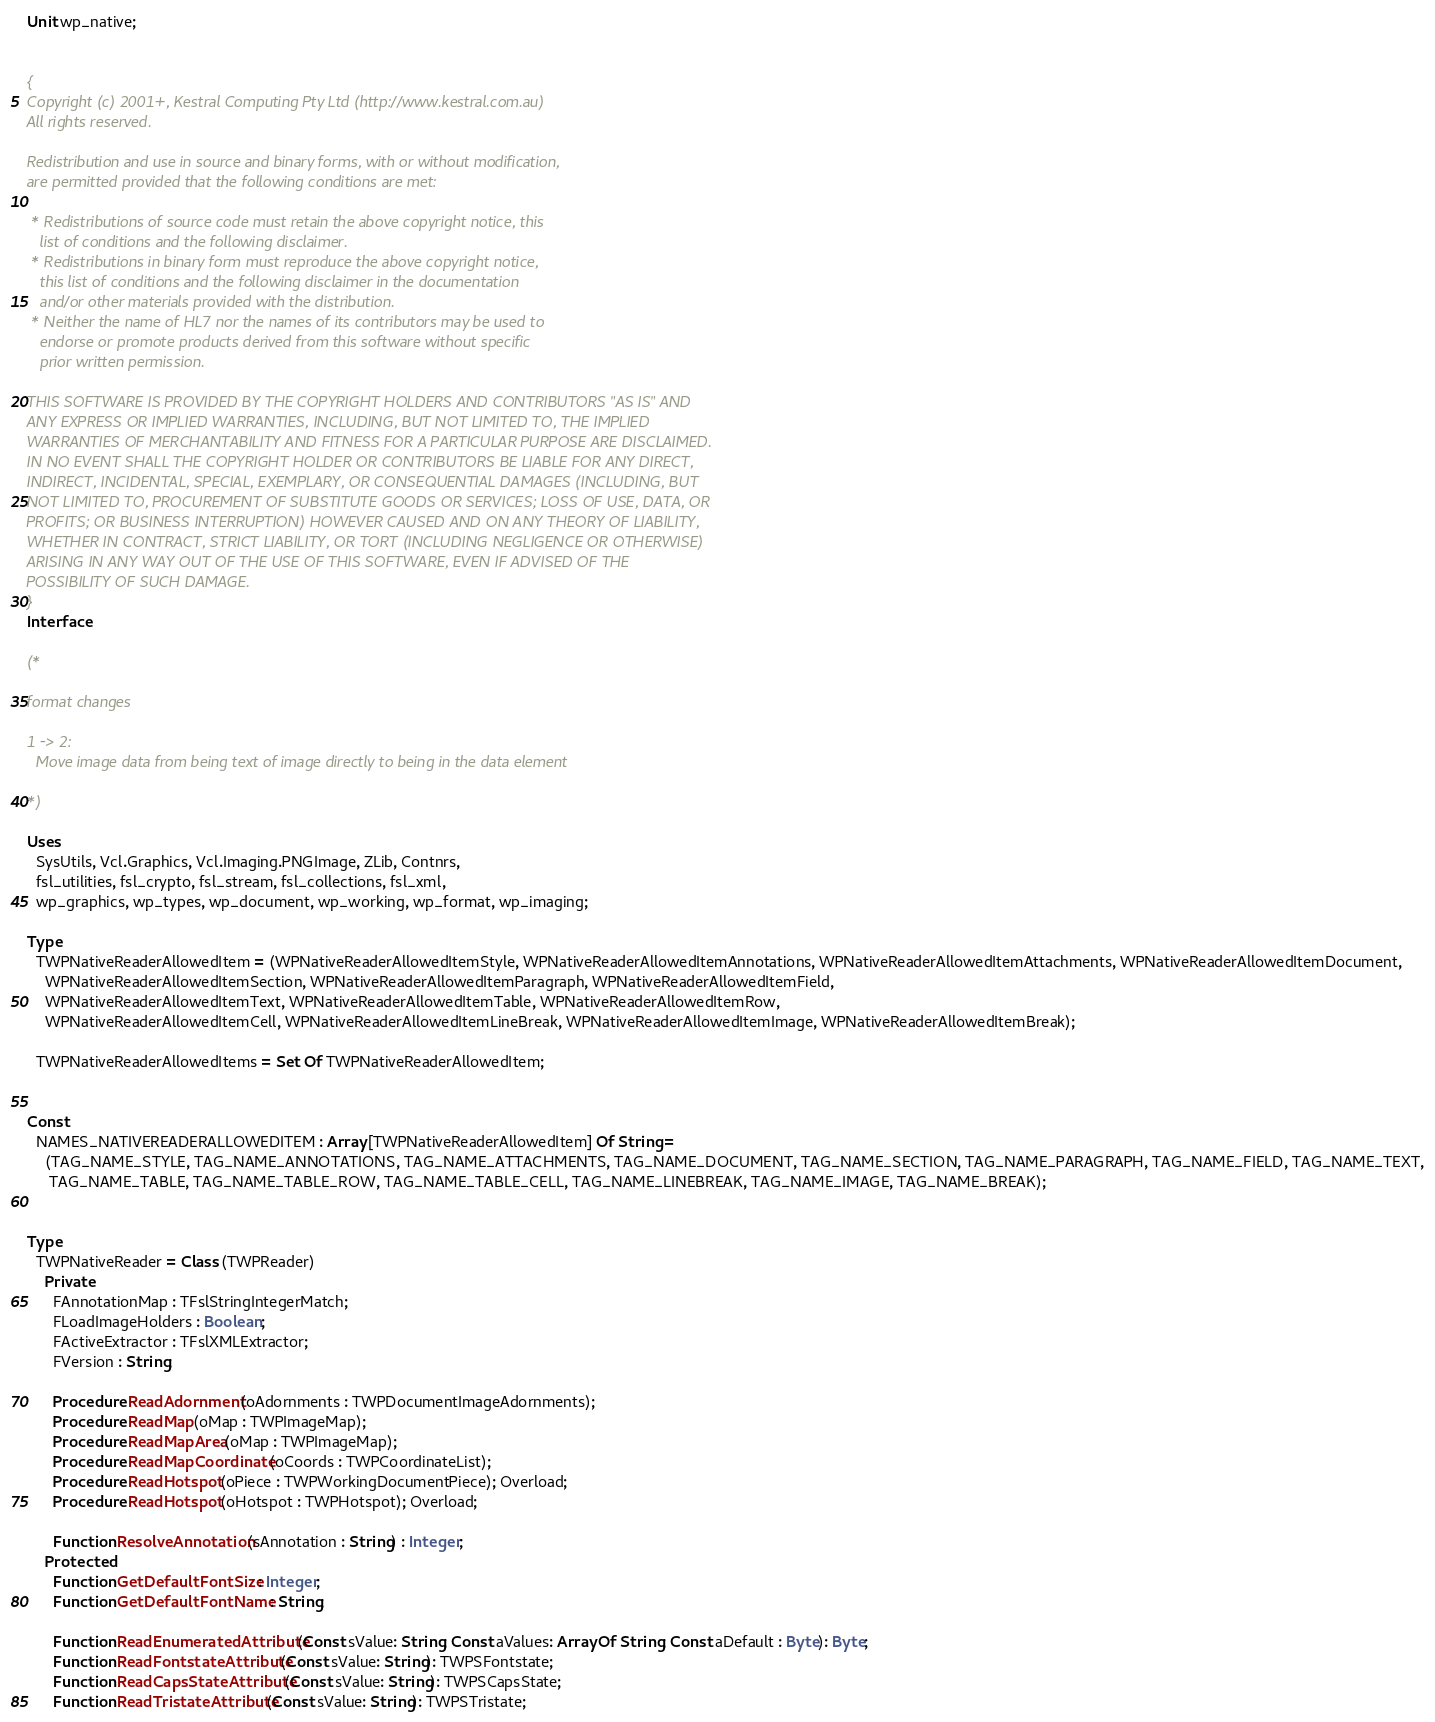Convert code to text. <code><loc_0><loc_0><loc_500><loc_500><_Pascal_>Unit wp_native;


{
Copyright (c) 2001+, Kestral Computing Pty Ltd (http://www.kestral.com.au)
All rights reserved.

Redistribution and use in source and binary forms, with or without modification,
are permitted provided that the following conditions are met:

 * Redistributions of source code must retain the above copyright notice, this
   list of conditions and the following disclaimer.
 * Redistributions in binary form must reproduce the above copyright notice,
   this list of conditions and the following disclaimer in the documentation
   and/or other materials provided with the distribution.
 * Neither the name of HL7 nor the names of its contributors may be used to
   endorse or promote products derived from this software without specific
   prior written permission.

THIS SOFTWARE IS PROVIDED BY THE COPYRIGHT HOLDERS AND CONTRIBUTORS "AS IS" AND
ANY EXPRESS OR IMPLIED WARRANTIES, INCLUDING, BUT NOT LIMITED TO, THE IMPLIED
WARRANTIES OF MERCHANTABILITY AND FITNESS FOR A PARTICULAR PURPOSE ARE DISCLAIMED.
IN NO EVENT SHALL THE COPYRIGHT HOLDER OR CONTRIBUTORS BE LIABLE FOR ANY DIRECT,
INDIRECT, INCIDENTAL, SPECIAL, EXEMPLARY, OR CONSEQUENTIAL DAMAGES (INCLUDING, BUT
NOT LIMITED TO, PROCUREMENT OF SUBSTITUTE GOODS OR SERVICES; LOSS OF USE, DATA, OR
PROFITS; OR BUSINESS INTERRUPTION) HOWEVER CAUSED AND ON ANY THEORY OF LIABILITY,
WHETHER IN CONTRACT, STRICT LIABILITY, OR TORT (INCLUDING NEGLIGENCE OR OTHERWISE)
ARISING IN ANY WAY OUT OF THE USE OF THIS SOFTWARE, EVEN IF ADVISED OF THE
POSSIBILITY OF SUCH DAMAGE.
}
Interface

(*

format changes

1 -> 2:
  Move image data from being text of image directly to being in the data element

*)

Uses
  SysUtils, Vcl.Graphics, Vcl.Imaging.PNGImage, ZLib, Contnrs,
  fsl_utilities, fsl_crypto, fsl_stream, fsl_collections, fsl_xml,
  wp_graphics, wp_types, wp_document, wp_working, wp_format, wp_imaging;

Type
  TWPNativeReaderAllowedItem = (WPNativeReaderAllowedItemStyle, WPNativeReaderAllowedItemAnnotations, WPNativeReaderAllowedItemAttachments, WPNativeReaderAllowedItemDocument,
    WPNativeReaderAllowedItemSection, WPNativeReaderAllowedItemParagraph, WPNativeReaderAllowedItemField,
    WPNativeReaderAllowedItemText, WPNativeReaderAllowedItemTable, WPNativeReaderAllowedItemRow,
    WPNativeReaderAllowedItemCell, WPNativeReaderAllowedItemLineBreak, WPNativeReaderAllowedItemImage, WPNativeReaderAllowedItemBreak);

  TWPNativeReaderAllowedItems = Set Of TWPNativeReaderAllowedItem;


Const
  NAMES_NATIVEREADERALLOWEDITEM : Array [TWPNativeReaderAllowedItem] Of String =
    (TAG_NAME_STYLE, TAG_NAME_ANNOTATIONS, TAG_NAME_ATTACHMENTS, TAG_NAME_DOCUMENT, TAG_NAME_SECTION, TAG_NAME_PARAGRAPH, TAG_NAME_FIELD, TAG_NAME_TEXT,
     TAG_NAME_TABLE, TAG_NAME_TABLE_ROW, TAG_NAME_TABLE_CELL, TAG_NAME_LINEBREAK, TAG_NAME_IMAGE, TAG_NAME_BREAK);


Type
  TWPNativeReader = Class (TWPReader)
    Private
      FAnnotationMap : TFslStringIntegerMatch;
      FLoadImageHolders : Boolean;
      FActiveExtractor : TFslXMLExtractor;
      FVersion : String;

      Procedure ReadAdornment(oAdornments : TWPDocumentImageAdornments);
      Procedure ReadMap(oMap : TWPImageMap);
      Procedure ReadMapArea(oMap : TWPImageMap);
      Procedure ReadMapCoordinate(oCoords : TWPCoordinateList);
      Procedure ReadHotspot(oPiece : TWPWorkingDocumentPiece); Overload;
      Procedure ReadHotspot(oHotspot : TWPHotspot); Overload;

      Function ResolveAnnotation(sAnnotation : String) : Integer;
    Protected
      Function GetDefaultFontSize : Integer;
      Function GetDefaultFontName : String;

      Function ReadEnumeratedAttribute(Const sValue: String; Const aValues: Array Of String; Const aDefault : Byte): Byte;
      Function ReadFontstateAttribute(Const sValue: String): TWPSFontstate;
      Function ReadCapsStateAttribute(Const sValue: String): TWPSCapsState;
      Function ReadTristateAttribute(Const sValue: String): TWPSTristate;
</code> 